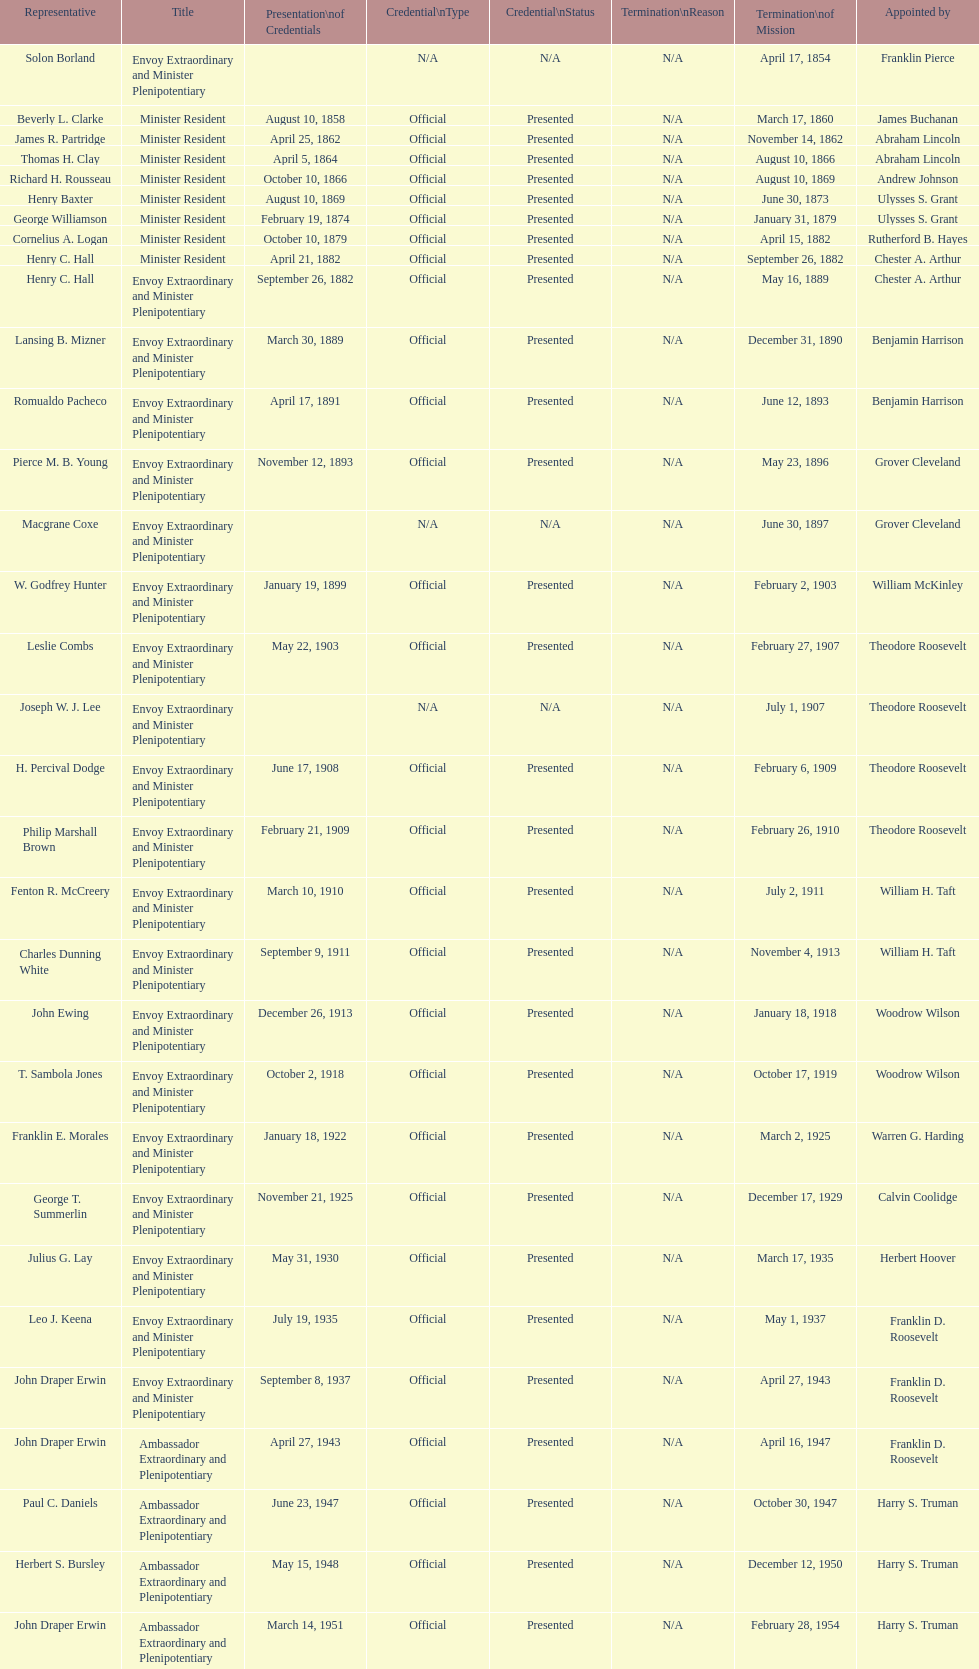Which ambassador to honduras served the longest term? Henry C. Hall. 